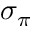<formula> <loc_0><loc_0><loc_500><loc_500>\sigma _ { \pi }</formula> 